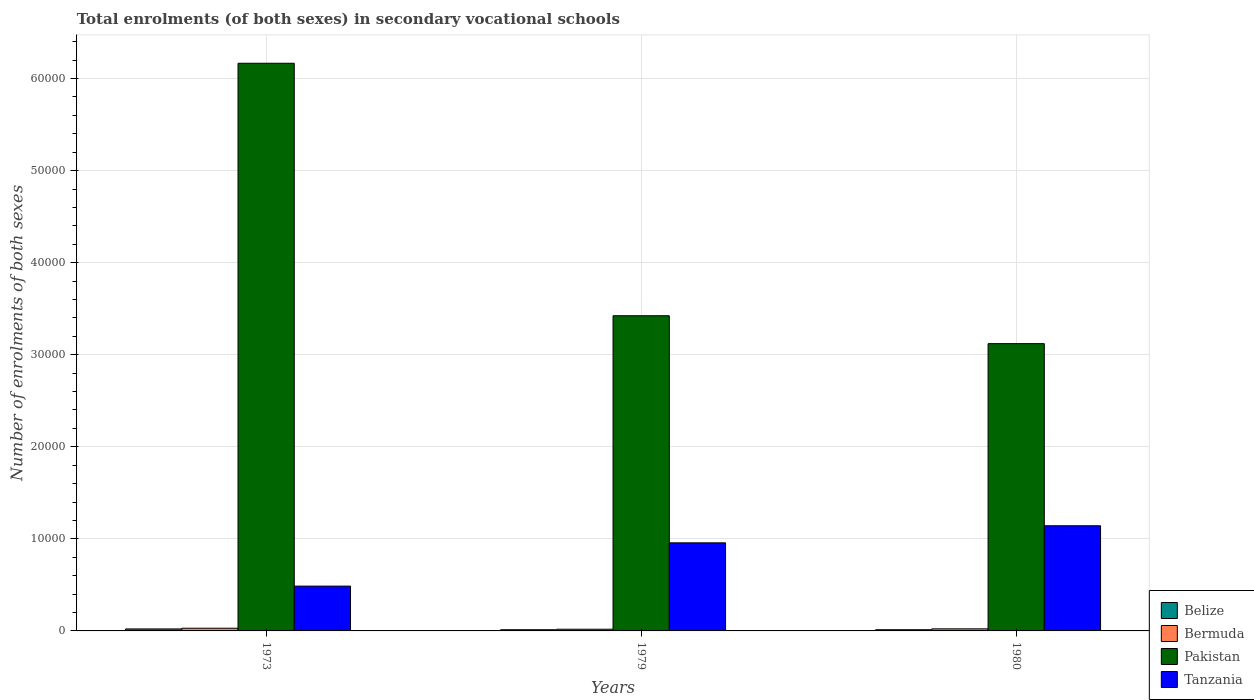How many groups of bars are there?
Your response must be concise. 3. Are the number of bars on each tick of the X-axis equal?
Keep it short and to the point. Yes. How many bars are there on the 1st tick from the right?
Your response must be concise. 4. In how many cases, is the number of bars for a given year not equal to the number of legend labels?
Your response must be concise. 0. What is the number of enrolments in secondary schools in Belize in 1980?
Your answer should be compact. 130. Across all years, what is the maximum number of enrolments in secondary schools in Pakistan?
Give a very brief answer. 6.17e+04. Across all years, what is the minimum number of enrolments in secondary schools in Pakistan?
Ensure brevity in your answer.  3.12e+04. In which year was the number of enrolments in secondary schools in Bermuda minimum?
Give a very brief answer. 1979. What is the total number of enrolments in secondary schools in Tanzania in the graph?
Provide a short and direct response. 2.59e+04. What is the difference between the number of enrolments in secondary schools in Pakistan in 1973 and that in 1979?
Offer a very short reply. 2.74e+04. What is the difference between the number of enrolments in secondary schools in Bermuda in 1979 and the number of enrolments in secondary schools in Pakistan in 1980?
Make the answer very short. -3.10e+04. What is the average number of enrolments in secondary schools in Tanzania per year?
Your answer should be very brief. 8618.67. In the year 1980, what is the difference between the number of enrolments in secondary schools in Pakistan and number of enrolments in secondary schools in Tanzania?
Your answer should be compact. 1.98e+04. In how many years, is the number of enrolments in secondary schools in Belize greater than 62000?
Offer a terse response. 0. What is the ratio of the number of enrolments in secondary schools in Tanzania in 1973 to that in 1980?
Give a very brief answer. 0.43. Is the number of enrolments in secondary schools in Pakistan in 1973 less than that in 1979?
Provide a succinct answer. No. Is the difference between the number of enrolments in secondary schools in Pakistan in 1979 and 1980 greater than the difference between the number of enrolments in secondary schools in Tanzania in 1979 and 1980?
Offer a terse response. Yes. What is the difference between the highest and the second highest number of enrolments in secondary schools in Bermuda?
Ensure brevity in your answer.  66. What is the difference between the highest and the lowest number of enrolments in secondary schools in Pakistan?
Offer a terse response. 3.05e+04. In how many years, is the number of enrolments in secondary schools in Pakistan greater than the average number of enrolments in secondary schools in Pakistan taken over all years?
Offer a very short reply. 1. Is the sum of the number of enrolments in secondary schools in Pakistan in 1973 and 1979 greater than the maximum number of enrolments in secondary schools in Tanzania across all years?
Ensure brevity in your answer.  Yes. Is it the case that in every year, the sum of the number of enrolments in secondary schools in Pakistan and number of enrolments in secondary schools in Tanzania is greater than the sum of number of enrolments in secondary schools in Bermuda and number of enrolments in secondary schools in Belize?
Provide a short and direct response. Yes. What does the 2nd bar from the left in 1973 represents?
Your response must be concise. Bermuda. What is the difference between two consecutive major ticks on the Y-axis?
Ensure brevity in your answer.  10000. Are the values on the major ticks of Y-axis written in scientific E-notation?
Offer a terse response. No. Where does the legend appear in the graph?
Provide a short and direct response. Bottom right. How many legend labels are there?
Offer a very short reply. 4. How are the legend labels stacked?
Ensure brevity in your answer.  Vertical. What is the title of the graph?
Make the answer very short. Total enrolments (of both sexes) in secondary vocational schools. Does "Germany" appear as one of the legend labels in the graph?
Keep it short and to the point. No. What is the label or title of the X-axis?
Provide a succinct answer. Years. What is the label or title of the Y-axis?
Your answer should be very brief. Number of enrolments of both sexes. What is the Number of enrolments of both sexes in Belize in 1973?
Your response must be concise. 217. What is the Number of enrolments of both sexes in Bermuda in 1973?
Your response must be concise. 293. What is the Number of enrolments of both sexes of Pakistan in 1973?
Provide a succinct answer. 6.17e+04. What is the Number of enrolments of both sexes in Tanzania in 1973?
Offer a terse response. 4866. What is the Number of enrolments of both sexes in Belize in 1979?
Keep it short and to the point. 130. What is the Number of enrolments of both sexes in Bermuda in 1979?
Give a very brief answer. 184. What is the Number of enrolments of both sexes of Pakistan in 1979?
Keep it short and to the point. 3.42e+04. What is the Number of enrolments of both sexes of Tanzania in 1979?
Your answer should be compact. 9567. What is the Number of enrolments of both sexes in Belize in 1980?
Your answer should be very brief. 130. What is the Number of enrolments of both sexes of Bermuda in 1980?
Your answer should be compact. 227. What is the Number of enrolments of both sexes of Pakistan in 1980?
Your answer should be compact. 3.12e+04. What is the Number of enrolments of both sexes in Tanzania in 1980?
Offer a terse response. 1.14e+04. Across all years, what is the maximum Number of enrolments of both sexes in Belize?
Provide a succinct answer. 217. Across all years, what is the maximum Number of enrolments of both sexes of Bermuda?
Offer a very short reply. 293. Across all years, what is the maximum Number of enrolments of both sexes of Pakistan?
Provide a succinct answer. 6.17e+04. Across all years, what is the maximum Number of enrolments of both sexes of Tanzania?
Keep it short and to the point. 1.14e+04. Across all years, what is the minimum Number of enrolments of both sexes in Belize?
Keep it short and to the point. 130. Across all years, what is the minimum Number of enrolments of both sexes in Bermuda?
Your answer should be very brief. 184. Across all years, what is the minimum Number of enrolments of both sexes in Pakistan?
Your response must be concise. 3.12e+04. Across all years, what is the minimum Number of enrolments of both sexes of Tanzania?
Offer a terse response. 4866. What is the total Number of enrolments of both sexes in Belize in the graph?
Provide a succinct answer. 477. What is the total Number of enrolments of both sexes of Bermuda in the graph?
Keep it short and to the point. 704. What is the total Number of enrolments of both sexes of Pakistan in the graph?
Give a very brief answer. 1.27e+05. What is the total Number of enrolments of both sexes of Tanzania in the graph?
Ensure brevity in your answer.  2.59e+04. What is the difference between the Number of enrolments of both sexes in Bermuda in 1973 and that in 1979?
Your answer should be compact. 109. What is the difference between the Number of enrolments of both sexes in Pakistan in 1973 and that in 1979?
Your answer should be compact. 2.74e+04. What is the difference between the Number of enrolments of both sexes of Tanzania in 1973 and that in 1979?
Your response must be concise. -4701. What is the difference between the Number of enrolments of both sexes in Pakistan in 1973 and that in 1980?
Your answer should be compact. 3.05e+04. What is the difference between the Number of enrolments of both sexes of Tanzania in 1973 and that in 1980?
Offer a very short reply. -6557. What is the difference between the Number of enrolments of both sexes of Belize in 1979 and that in 1980?
Ensure brevity in your answer.  0. What is the difference between the Number of enrolments of both sexes of Bermuda in 1979 and that in 1980?
Provide a succinct answer. -43. What is the difference between the Number of enrolments of both sexes in Pakistan in 1979 and that in 1980?
Offer a very short reply. 3031. What is the difference between the Number of enrolments of both sexes in Tanzania in 1979 and that in 1980?
Provide a succinct answer. -1856. What is the difference between the Number of enrolments of both sexes of Belize in 1973 and the Number of enrolments of both sexes of Pakistan in 1979?
Your response must be concise. -3.40e+04. What is the difference between the Number of enrolments of both sexes in Belize in 1973 and the Number of enrolments of both sexes in Tanzania in 1979?
Make the answer very short. -9350. What is the difference between the Number of enrolments of both sexes of Bermuda in 1973 and the Number of enrolments of both sexes of Pakistan in 1979?
Provide a short and direct response. -3.39e+04. What is the difference between the Number of enrolments of both sexes in Bermuda in 1973 and the Number of enrolments of both sexes in Tanzania in 1979?
Keep it short and to the point. -9274. What is the difference between the Number of enrolments of both sexes of Pakistan in 1973 and the Number of enrolments of both sexes of Tanzania in 1979?
Provide a short and direct response. 5.21e+04. What is the difference between the Number of enrolments of both sexes in Belize in 1973 and the Number of enrolments of both sexes in Pakistan in 1980?
Your response must be concise. -3.10e+04. What is the difference between the Number of enrolments of both sexes of Belize in 1973 and the Number of enrolments of both sexes of Tanzania in 1980?
Your response must be concise. -1.12e+04. What is the difference between the Number of enrolments of both sexes of Bermuda in 1973 and the Number of enrolments of both sexes of Pakistan in 1980?
Your answer should be very brief. -3.09e+04. What is the difference between the Number of enrolments of both sexes in Bermuda in 1973 and the Number of enrolments of both sexes in Tanzania in 1980?
Offer a terse response. -1.11e+04. What is the difference between the Number of enrolments of both sexes of Pakistan in 1973 and the Number of enrolments of both sexes of Tanzania in 1980?
Give a very brief answer. 5.02e+04. What is the difference between the Number of enrolments of both sexes in Belize in 1979 and the Number of enrolments of both sexes in Bermuda in 1980?
Provide a succinct answer. -97. What is the difference between the Number of enrolments of both sexes in Belize in 1979 and the Number of enrolments of both sexes in Pakistan in 1980?
Your answer should be very brief. -3.11e+04. What is the difference between the Number of enrolments of both sexes of Belize in 1979 and the Number of enrolments of both sexes of Tanzania in 1980?
Offer a terse response. -1.13e+04. What is the difference between the Number of enrolments of both sexes in Bermuda in 1979 and the Number of enrolments of both sexes in Pakistan in 1980?
Give a very brief answer. -3.10e+04. What is the difference between the Number of enrolments of both sexes in Bermuda in 1979 and the Number of enrolments of both sexes in Tanzania in 1980?
Keep it short and to the point. -1.12e+04. What is the difference between the Number of enrolments of both sexes in Pakistan in 1979 and the Number of enrolments of both sexes in Tanzania in 1980?
Provide a succinct answer. 2.28e+04. What is the average Number of enrolments of both sexes in Belize per year?
Provide a succinct answer. 159. What is the average Number of enrolments of both sexes of Bermuda per year?
Offer a terse response. 234.67. What is the average Number of enrolments of both sexes in Pakistan per year?
Your answer should be compact. 4.24e+04. What is the average Number of enrolments of both sexes of Tanzania per year?
Provide a succinct answer. 8618.67. In the year 1973, what is the difference between the Number of enrolments of both sexes in Belize and Number of enrolments of both sexes in Bermuda?
Your answer should be compact. -76. In the year 1973, what is the difference between the Number of enrolments of both sexes in Belize and Number of enrolments of both sexes in Pakistan?
Your response must be concise. -6.14e+04. In the year 1973, what is the difference between the Number of enrolments of both sexes of Belize and Number of enrolments of both sexes of Tanzania?
Your response must be concise. -4649. In the year 1973, what is the difference between the Number of enrolments of both sexes in Bermuda and Number of enrolments of both sexes in Pakistan?
Provide a succinct answer. -6.14e+04. In the year 1973, what is the difference between the Number of enrolments of both sexes in Bermuda and Number of enrolments of both sexes in Tanzania?
Your answer should be very brief. -4573. In the year 1973, what is the difference between the Number of enrolments of both sexes in Pakistan and Number of enrolments of both sexes in Tanzania?
Your answer should be compact. 5.68e+04. In the year 1979, what is the difference between the Number of enrolments of both sexes of Belize and Number of enrolments of both sexes of Bermuda?
Give a very brief answer. -54. In the year 1979, what is the difference between the Number of enrolments of both sexes of Belize and Number of enrolments of both sexes of Pakistan?
Provide a succinct answer. -3.41e+04. In the year 1979, what is the difference between the Number of enrolments of both sexes in Belize and Number of enrolments of both sexes in Tanzania?
Offer a terse response. -9437. In the year 1979, what is the difference between the Number of enrolments of both sexes of Bermuda and Number of enrolments of both sexes of Pakistan?
Make the answer very short. -3.41e+04. In the year 1979, what is the difference between the Number of enrolments of both sexes in Bermuda and Number of enrolments of both sexes in Tanzania?
Ensure brevity in your answer.  -9383. In the year 1979, what is the difference between the Number of enrolments of both sexes of Pakistan and Number of enrolments of both sexes of Tanzania?
Your answer should be very brief. 2.47e+04. In the year 1980, what is the difference between the Number of enrolments of both sexes of Belize and Number of enrolments of both sexes of Bermuda?
Provide a succinct answer. -97. In the year 1980, what is the difference between the Number of enrolments of both sexes in Belize and Number of enrolments of both sexes in Pakistan?
Keep it short and to the point. -3.11e+04. In the year 1980, what is the difference between the Number of enrolments of both sexes in Belize and Number of enrolments of both sexes in Tanzania?
Your response must be concise. -1.13e+04. In the year 1980, what is the difference between the Number of enrolments of both sexes of Bermuda and Number of enrolments of both sexes of Pakistan?
Your response must be concise. -3.10e+04. In the year 1980, what is the difference between the Number of enrolments of both sexes in Bermuda and Number of enrolments of both sexes in Tanzania?
Offer a terse response. -1.12e+04. In the year 1980, what is the difference between the Number of enrolments of both sexes in Pakistan and Number of enrolments of both sexes in Tanzania?
Your answer should be compact. 1.98e+04. What is the ratio of the Number of enrolments of both sexes of Belize in 1973 to that in 1979?
Make the answer very short. 1.67. What is the ratio of the Number of enrolments of both sexes of Bermuda in 1973 to that in 1979?
Your response must be concise. 1.59. What is the ratio of the Number of enrolments of both sexes in Pakistan in 1973 to that in 1979?
Keep it short and to the point. 1.8. What is the ratio of the Number of enrolments of both sexes in Tanzania in 1973 to that in 1979?
Your answer should be very brief. 0.51. What is the ratio of the Number of enrolments of both sexes in Belize in 1973 to that in 1980?
Provide a short and direct response. 1.67. What is the ratio of the Number of enrolments of both sexes in Bermuda in 1973 to that in 1980?
Your answer should be very brief. 1.29. What is the ratio of the Number of enrolments of both sexes in Pakistan in 1973 to that in 1980?
Provide a short and direct response. 1.98. What is the ratio of the Number of enrolments of both sexes of Tanzania in 1973 to that in 1980?
Provide a succinct answer. 0.43. What is the ratio of the Number of enrolments of both sexes in Bermuda in 1979 to that in 1980?
Provide a short and direct response. 0.81. What is the ratio of the Number of enrolments of both sexes of Pakistan in 1979 to that in 1980?
Provide a succinct answer. 1.1. What is the ratio of the Number of enrolments of both sexes in Tanzania in 1979 to that in 1980?
Offer a very short reply. 0.84. What is the difference between the highest and the second highest Number of enrolments of both sexes of Belize?
Offer a very short reply. 87. What is the difference between the highest and the second highest Number of enrolments of both sexes in Pakistan?
Provide a short and direct response. 2.74e+04. What is the difference between the highest and the second highest Number of enrolments of both sexes of Tanzania?
Give a very brief answer. 1856. What is the difference between the highest and the lowest Number of enrolments of both sexes in Bermuda?
Offer a terse response. 109. What is the difference between the highest and the lowest Number of enrolments of both sexes of Pakistan?
Ensure brevity in your answer.  3.05e+04. What is the difference between the highest and the lowest Number of enrolments of both sexes of Tanzania?
Keep it short and to the point. 6557. 